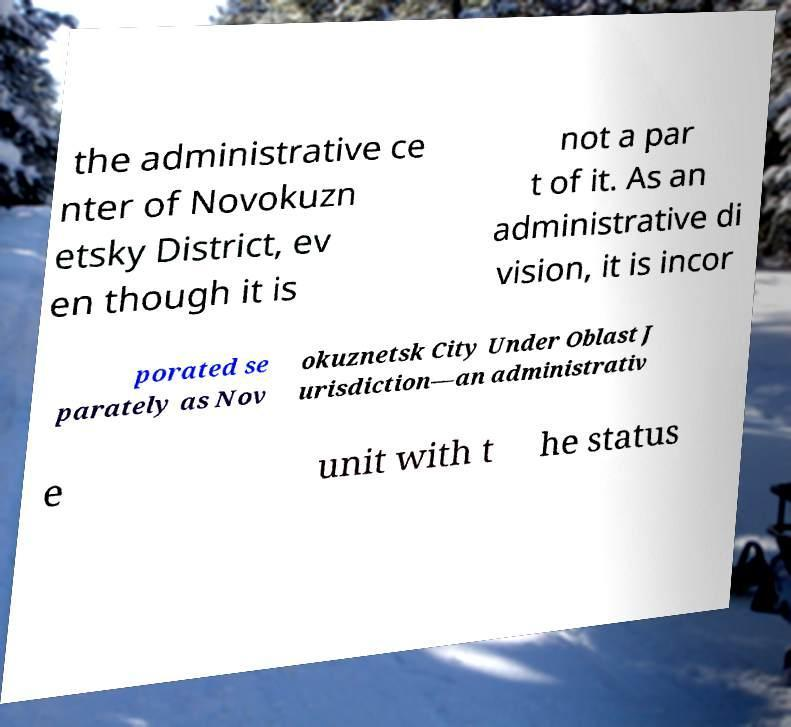Could you extract and type out the text from this image? the administrative ce nter of Novokuzn etsky District, ev en though it is not a par t of it. As an administrative di vision, it is incor porated se parately as Nov okuznetsk City Under Oblast J urisdiction—an administrativ e unit with t he status 